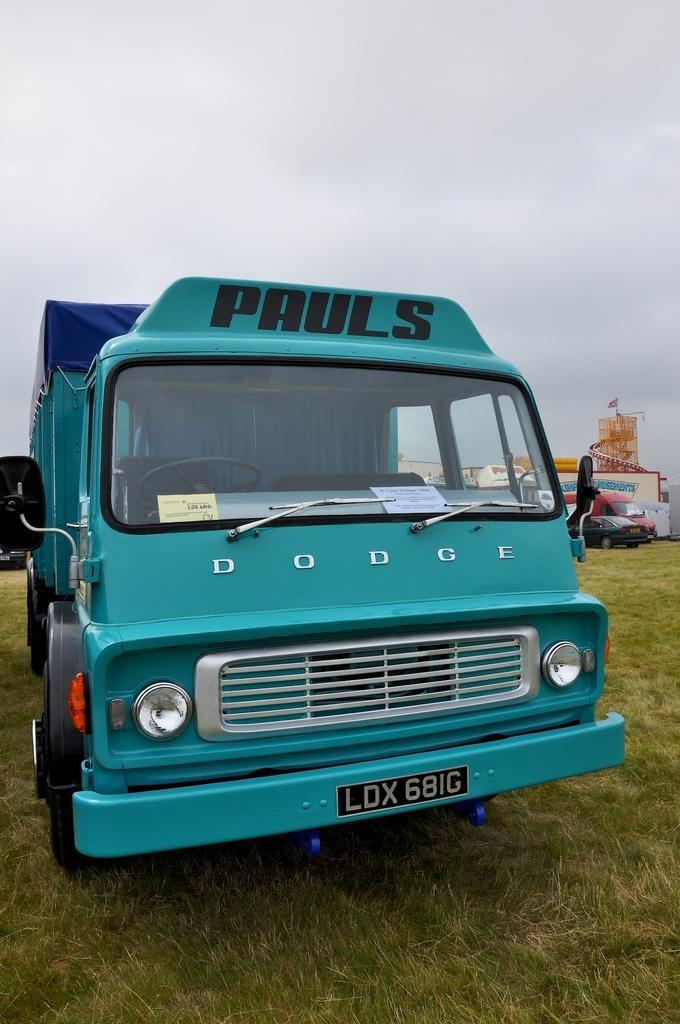Please provide a concise description of this image. In this image I can see a vehicle in green color, background I can see few other vehicles and sky in white color. 